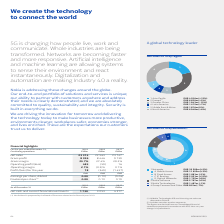According to Nokia Corporation's financial document, Nokia Techonologies IPR and Licensing net sales are allocated to which country? According to the financial document, Finland. The relevant text states: "gies IPR and Licensing net sales are allocated to Finland. (2) Includes net sales to other segments. The figures are derived from our consolidated financial..." Also, What is the proposed dividend for financial year 2019?  According to the financial document, 0.00. The relevant text states: "Earnings per share, diluted 0.00 (0.10) (0.26) Dividend per share (1) 0.00 0.10 0.19..." Also, What is the Gross margin for year ending 2019? According to the financial document, 35.7%. The relevant text states: "23 147 Gross profit 8 326 8 446 9 139 Gross margin 35.7% 37.4% 39.5% Operating profit/(loss) 485 (59) 16 Operating margin 2.1% (0.3)% 0.1% Profit/(loss) for..." Also, can you calculate: What is the increase / (decrease) in Gross profit from 2018 to 2019? Based on the calculation: 8,326 - 8,446, the result is -120 (in millions). The key data points involved are: 8,326, 8,446. Also, can you calculate: What is the average Profit/(loss) for the year in the last 3 years? To answer this question, I need to perform calculations using the financial data. The calculation is: (18 - 549 - 1,437) / 3, which equals -656 (in millions). This is based on the information: "1 Networks EUR 18 209m (+5%) A Mobile Access EUR 11 655m (+3%) B Fixed Access EUR 1 881m (-5%) C IP Routing EUR 2 921 n 2.1% (0.3)% 0.1% Profit/(loss) for the year 18 (549) (1 437)..." The key data points involved are: 1,437, 18, 549. Also, can you calculate: What is the percentage increase / (decrease) in Net cash and current financial investments from 2018 to 2019? To answer this question, I need to perform calculations using the financial data. The calculation is: 1,730 / 3,053 - 1, which equals -43.33 (percentage). The key data points involved are: 1,730, 3,053. 